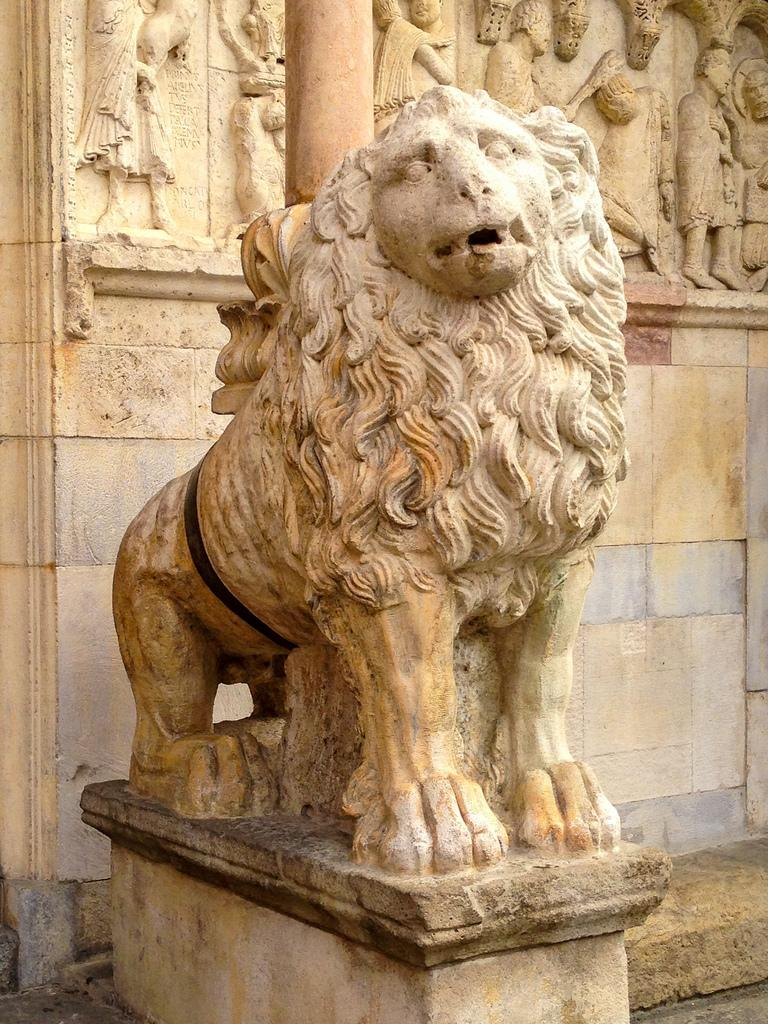What is the main subject in the center of the image? There is a sculpture of an animal in the center of the image. What can be seen in the background of the image? There is a wall, additional sculptures, and a pillar in the background of the image. What is at the bottom of the image? There is a walkway at the bottom of the image. What type of glass is used to create the sculpture in the image? There is no mention of glass being used to create the sculpture in the image. The sculpture is likely made of a different material, such as stone or metal. 